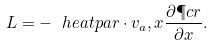Convert formula to latex. <formula><loc_0><loc_0><loc_500><loc_500>L = - \ h e a t p a r \cdot v _ { a } , x \frac { \partial \P c r } { \partial x } .</formula> 